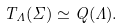Convert formula to latex. <formula><loc_0><loc_0><loc_500><loc_500>T _ { \Lambda } \L ( \Sigma ) \simeq Q ( \Lambda ) .</formula> 